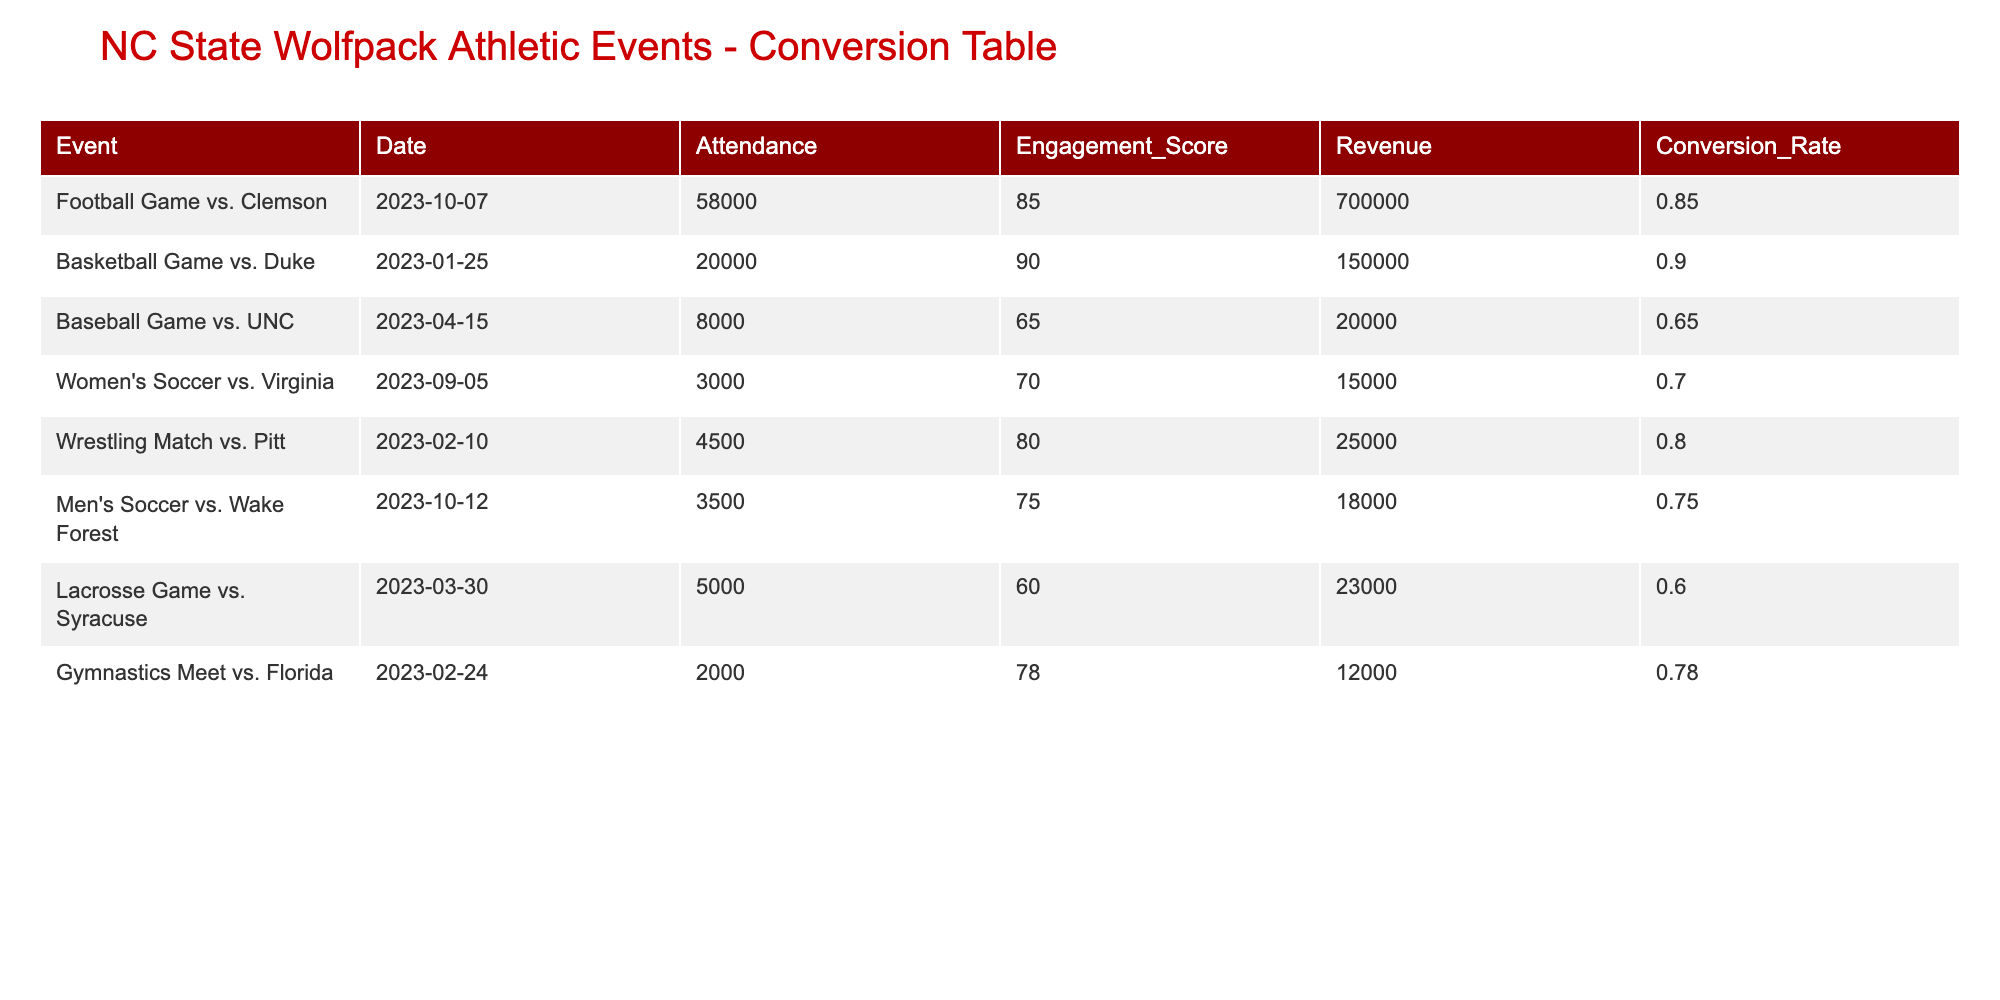What was the highest attendance recorded for an event? The highest attendance is found in the row for the football game vs. Clemson, which shows an attendance of 58,000.
Answer: 58000 What was the engagement score for the basketball game against Duke? The table shows the engagement score for the basketball game vs. Duke as 90.
Answer: 90 Is the revenue generated from the baseball game against UNC greater than that of the wrestling match against Pitt? The revenue for the baseball game vs. UNC is 20,000, while the wrestling match vs. Pitt generated 25,000. Since 20,000 is less than 25,000, the statement is false.
Answer: No What is the total revenue generated from all events listed in the table? To find the total revenue, we sum all the revenue values: 700000 + 150000 + 20000 + 15000 + 25000 + 18000 + 23000 + 12000 = 899000.
Answer: 899000 Which event had the lowest engagement score? By inspecting the engagement scores, the lacrosse game vs. Syracuse has the lowest score of 60.
Answer: Lacrosse Game vs. Syracuse Was the attendance for the women’s soccer game higher than that for men's soccer vs. Wake Forest? The women's soccer game against Virginia had an attendance of 3,000, while the men's soccer game against Wake Forest had an attendance of 3,500. Since 3,000 is less than 3,500, the answer is false.
Answer: No What is the average engagement score across all events? The average engagement score is calculated by summing all engagement scores (85 + 90 + 65 + 70 + 80 + 75 + 60 + 78 =  625) and dividing by the number of events (8). So, 625 ÷ 8 = 78.125.
Answer: 78.125 What event generated the highest revenue? The football game vs. Clemson generated the highest revenue at 700,000.
Answer: Football Game vs. Clemson Are there any events with an engagement score above 80 that had attendance below 10,000? There are no events with attendance below 10,000 that had an engagement score above 80, as the lowest attendance above 80 engagement score is 20,000 (basketball game vs. Duke). Therefore, the answer is true.
Answer: No 